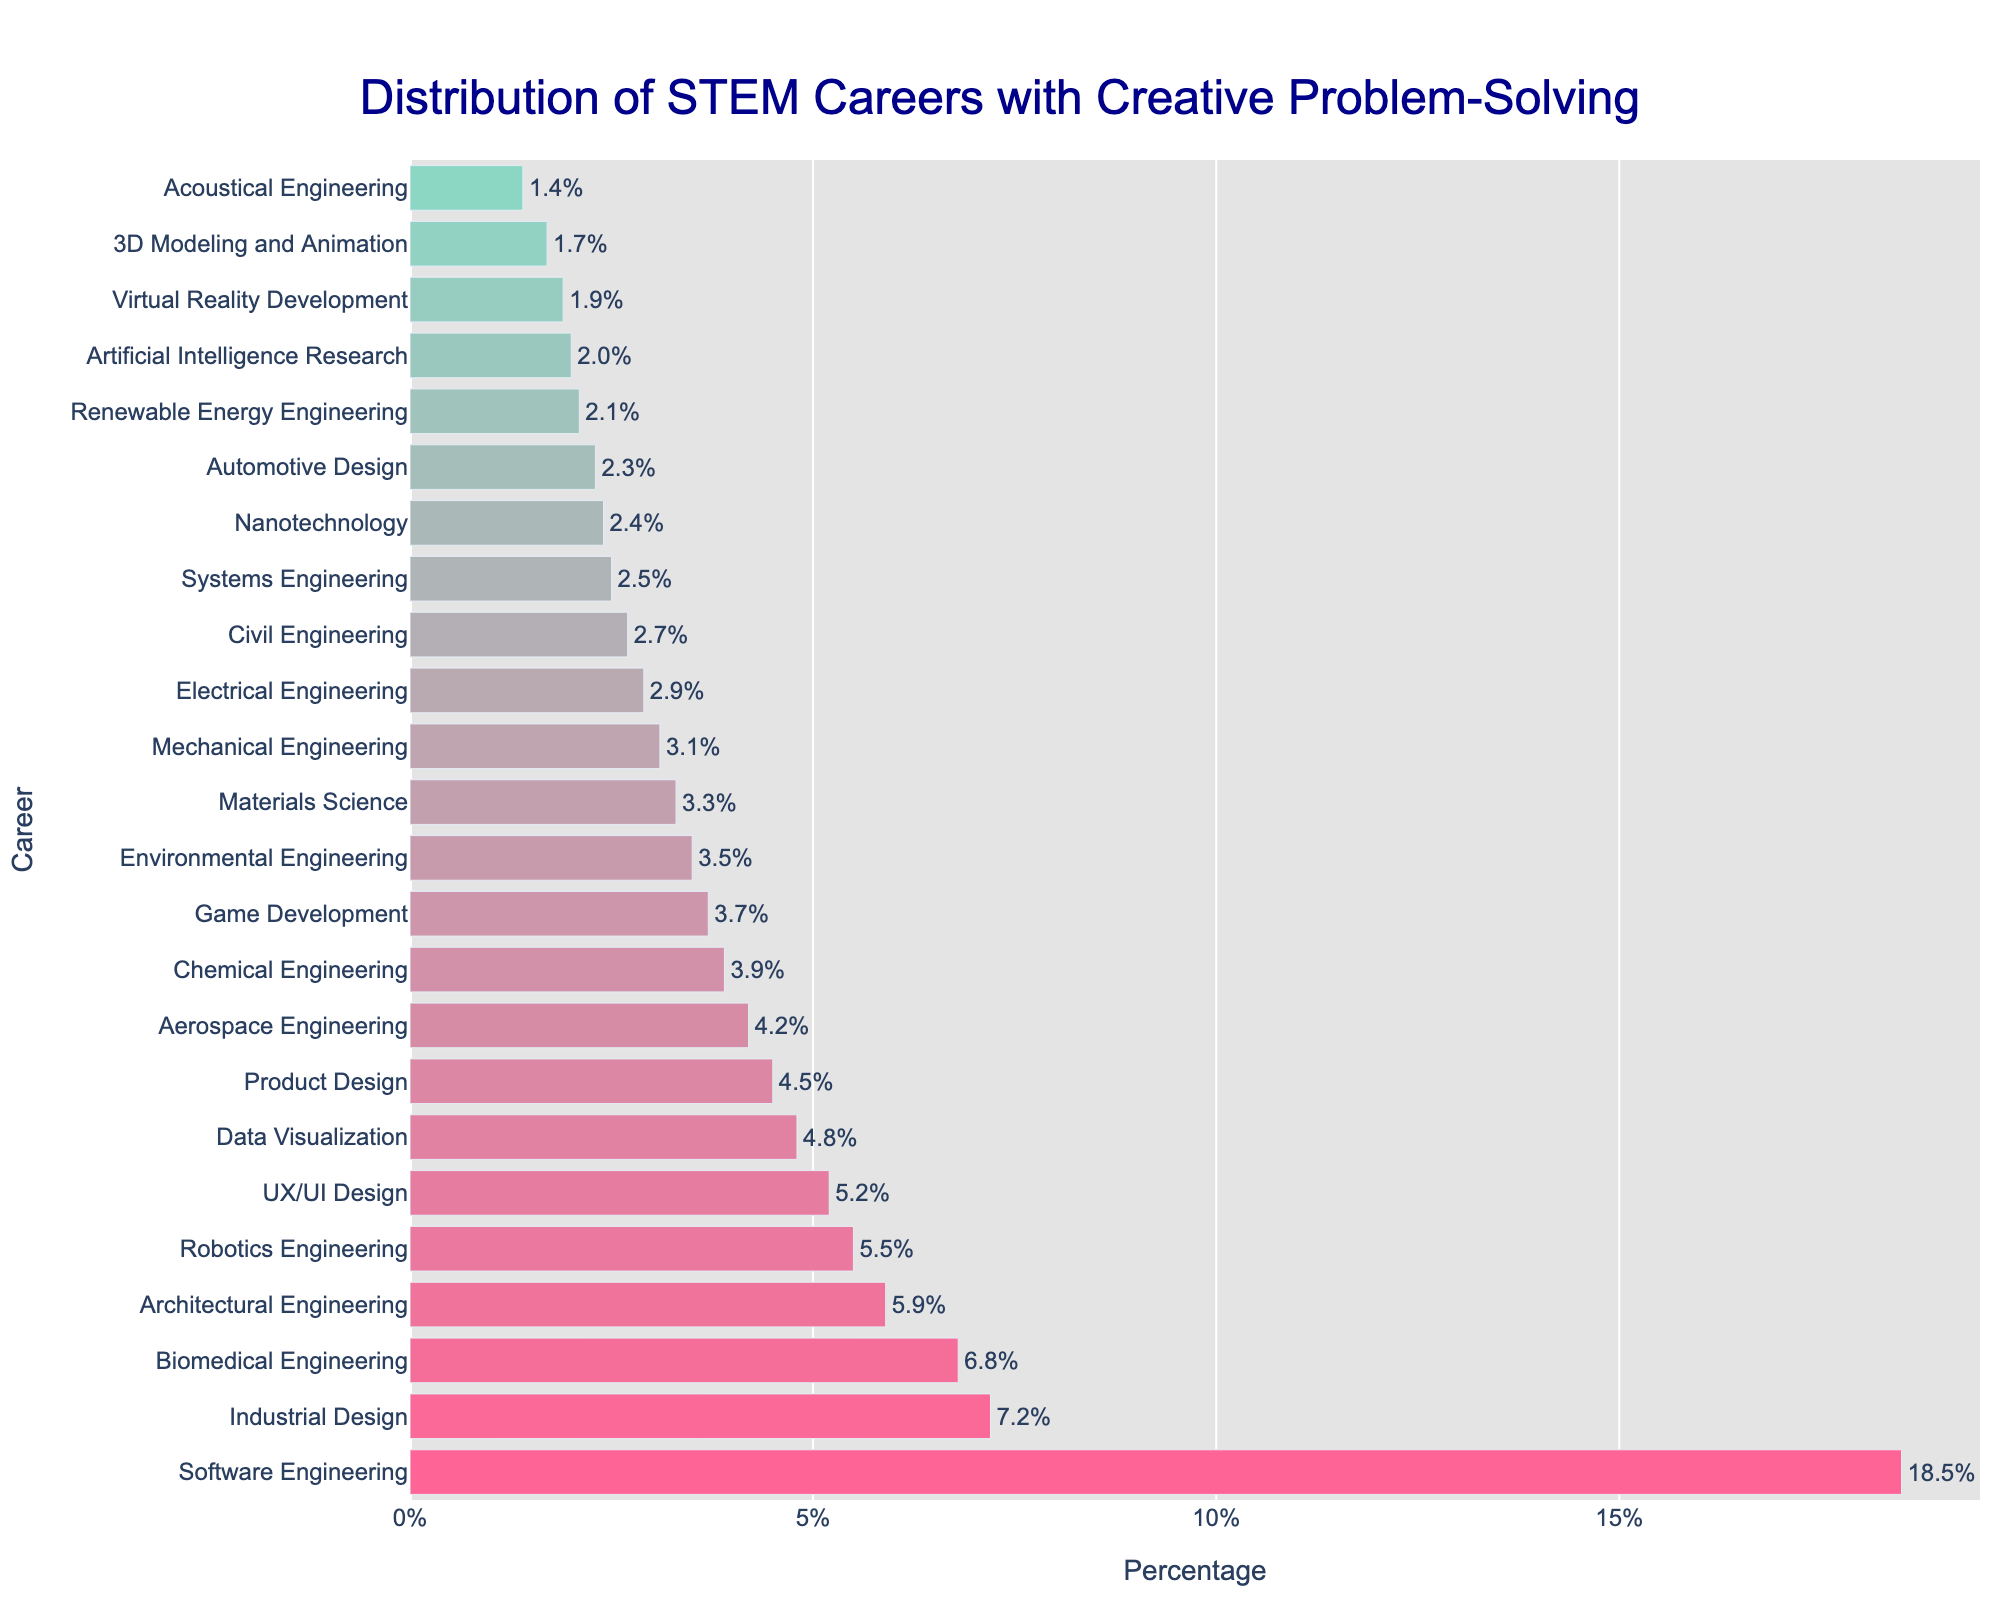Which career has the highest percentage in the distribution? The bar chart shows various STEM careers and their respective percentages. The career with the tallest bar has the highest percentage.
Answer: Software Engineering Which three careers have the lowest percentages? To find the three careers with the lowest percentages, look at the three shortest bars in the bar chart.
Answer: Acoustical Engineering, 3D Modeling and Animation, Virtual Reality Development What is the combined percentage of Data Visualization, Product Design, and Aerospace Engineering? The percentages for these careers are 4.8%, 4.5%, and 4.2% respectively. Sum these percentages to find the combined total. 4.8 + 4.5 + 4.2 = 13.5%
Answer: 13.5% Which is more prevalent, Biomedical Engineering or Chemical Engineering, and by how much? Compare the lengths of the bars for Biomedical Engineering and Chemical Engineering. The percentage for Biomedical Engineering is 6.8% and for Chemical Engineering is 3.9%. Subtract the smaller percentage from the larger one. 6.8% - 3.9% = 2.9%
Answer: Biomedical Engineering by 2.9% Is UX/UI Design more or less common than Mechanical Engineering? Compare the bars for UX/UI Design and Mechanical Engineering. UX/UI Design has a percentage of 5.2%, and Mechanical Engineering has 3.1%. Thus, UX/UI Design is more common.
Answer: More common What is the difference in percentage between the top career (Software Engineering) and the bottom career (Acoustical Engineering)? The top career, Software Engineering, has a percentage of 18.5%, and the bottom career, Acoustical Engineering, has 1.4%. Subtract the smaller percentage from the larger one. 18.5% - 1.4% = 17.1%
Answer: 17.1% How does the percentage of Industrial Design compare to that of Robotics Engineering? Compare the bar lengths for Industrial Design (7.2%) and Robotics Engineering (5.5%). Industrial Design has a higher percentage.
Answer: Industrial Design is higher Which has a higher percentage, Virtual Reality Development or Artificial Intelligence Research? Virtual Reality Development has a percentage of 1.9%, and Artificial Intelligence Research has 2.0%. Artificial Intelligence Research has a slightly higher percentage.
Answer: Artificial Intelligence Research What is the average percentage of the bottom five careers in the distribution? The bottom five careers are 3D Modeling and Animation (1.7%), Acoustical Engineering (1.4%), Virtual Reality Development (1.9%), Artificial Intelligence Research (2.0%), and Renewable Energy Engineering (2.1%). Find the sum and divide by 5. (1.7 + 1.4 + 1.9 + 2.0 + 2.1) / 5 = 1.82%
Answer: 1.82% What's the difference in percentage between Electrical Engineering and Nanotechnology? Electrical Engineering has a percentage of 2.9%, and Nanotechnology has 2.4%. Subtract the smaller percentage from the larger one. 2.9% - 2.4% = 0.5%
Answer: 0.5% 